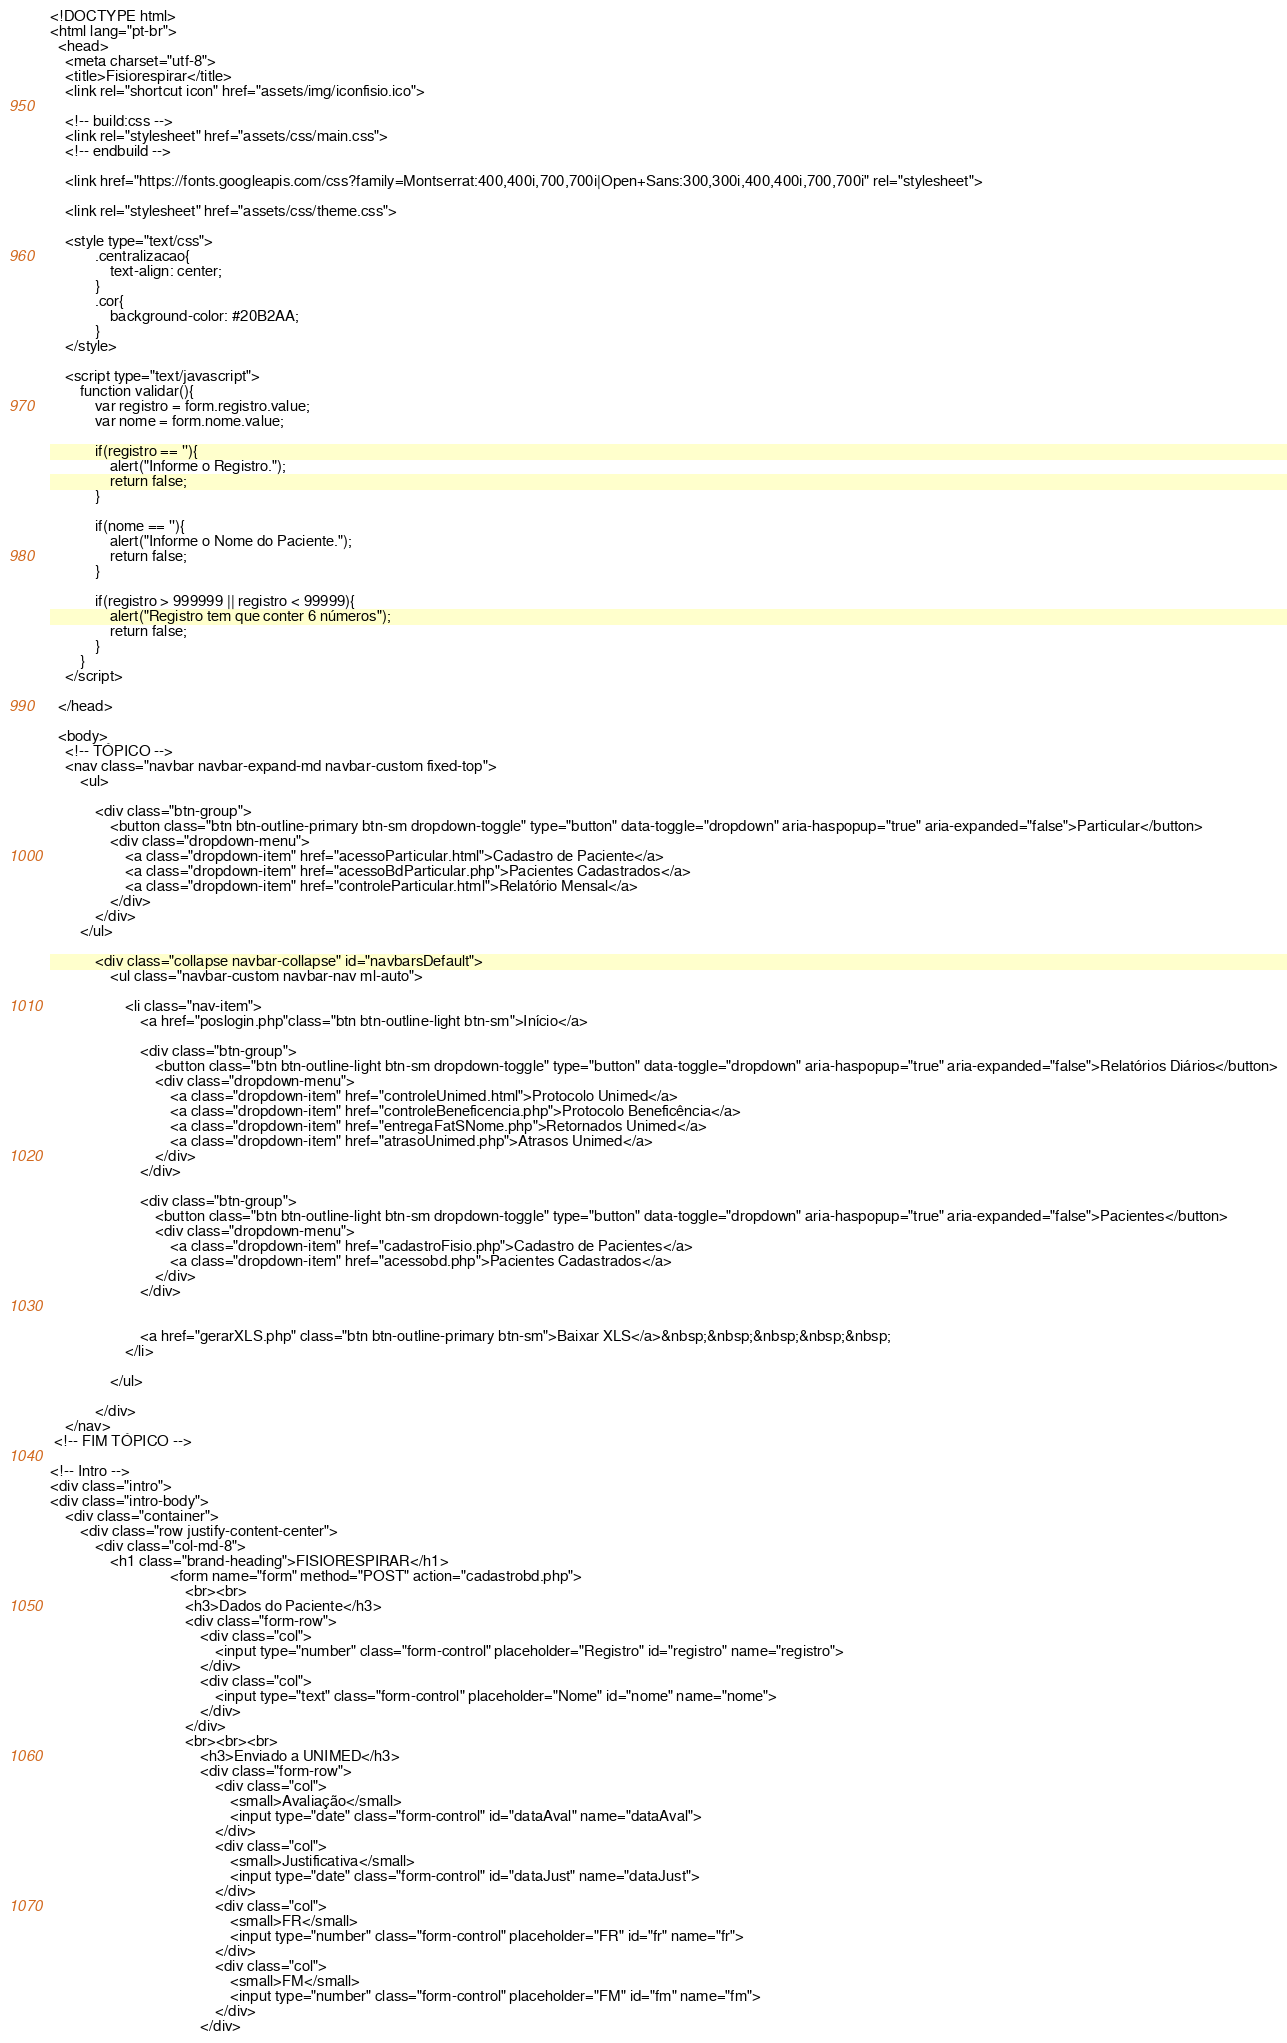<code> <loc_0><loc_0><loc_500><loc_500><_PHP_><!DOCTYPE html>
<html lang="pt-br">
  <head>
    <meta charset="utf-8">
    <title>Fisiorespirar</title>
    <link rel="shortcut icon" href="assets/img/iconfisio.ico">

    <!-- build:css -->
    <link rel="stylesheet" href="assets/css/main.css">
    <!-- endbuild -->
    
    <link href="https://fonts.googleapis.com/css?family=Montserrat:400,400i,700,700i|Open+Sans:300,300i,400,400i,700,700i" rel="stylesheet">
      
    <link rel="stylesheet" href="assets/css/theme.css">
    
    <style type="text/css">
            .centralizacao{
                text-align: center;
            }
            .cor{
                background-color: #20B2AA;
            }
    </style>
    
    <script type="text/javascript">  
        function validar(){
            var registro = form.registro.value;
            var nome = form.nome.value;
            
            if(registro == ''){
                alert("Informe o Registro.");
                return false;
            }       
            
            if(nome == ''){
                alert("Informe o Nome do Paciente.");
                return false;
            }     
            
            if(registro > 999999 || registro < 99999){
                alert("Registro tem que conter 6 números");
                return false;
            }
        }
    </script>
      
  </head>

  <body>     
    <!-- TÓPICO -->
    <nav class="navbar navbar-expand-md navbar-custom fixed-top">
        <ul>
            
            <div class="btn-group">
                <button class="btn btn-outline-primary btn-sm dropdown-toggle" type="button" data-toggle="dropdown" aria-haspopup="true" aria-expanded="false">Particular</button>
                <div class="dropdown-menu"> 
                    <a class="dropdown-item" href="acessoParticular.html">Cadastro de Paciente</a>
                    <a class="dropdown-item" href="acessoBdParticular.php">Pacientes Cadastrados</a>
                    <a class="dropdown-item" href="controleParticular.html">Relatório Mensal</a>                
                </div>
            </div>
        </ul>

            <div class="collapse navbar-collapse" id="navbarsDefault">
                <ul class="navbar-custom navbar-nav ml-auto">
                                        
                    <li class="nav-item">       
                        <a href="poslogin.php"class="btn btn-outline-light btn-sm">Início</a>
                        
                        <div class="btn-group">
                            <button class="btn btn-outline-light btn-sm dropdown-toggle" type="button" data-toggle="dropdown" aria-haspopup="true" aria-expanded="false">Relatórios Diários</button>
                            <div class="dropdown-menu"> 
                                <a class="dropdown-item" href="controleUnimed.html">Protocolo Unimed</a>
                                <a class="dropdown-item" href="controleBeneficencia.php">Protocolo Beneficência</a>
                                <a class="dropdown-item" href="entregaFatSNome.php">Retornados Unimed</a>
                                <a class="dropdown-item" href="atrasoUnimed.php">Atrasos Unimed</a>
                            </div>
                        </div>
                     
                        <div class="btn-group">
                            <button class="btn btn-outline-light btn-sm dropdown-toggle" type="button" data-toggle="dropdown" aria-haspopup="true" aria-expanded="false">Pacientes</button>
                            <div class="dropdown-menu"> 
                                <a class="dropdown-item" href="cadastroFisio.php">Cadastro de Pacientes</a>
                                <a class="dropdown-item" href="acessobd.php">Pacientes Cadastrados</a>                
                            </div>
                        </div>

                    
                        <a href="gerarXLS.php" class="btn btn-outline-primary btn-sm">Baixar XLS</a>&nbsp;&nbsp;&nbsp;&nbsp;&nbsp;
                    </li>  
                    
                </ul>              
                
            </div>
    </nav>
 <!-- FIM TÓPICO -->

<!-- Intro -->
<div class="intro">
<div class="intro-body">
	<div class="container">
		<div class="row justify-content-center">
			<div class="col-md-8">
				<h1 class="brand-heading">FISIORESPIRAR</h1>
                                <form name="form" method="POST" action="cadastrobd.php">
                                    <br><br>
                                    <h3>Dados do Paciente</h3>
                                    <div class="form-row">                                        
                                        <div class="col">
                                            <input type="number" class="form-control" placeholder="Registro" id="registro" name="registro">
                                        </div>
                                        <div class="col">
                                            <input type="text" class="form-control" placeholder="Nome" id="nome" name="nome">
                                        </div>
                                    </div>
                                    <br><br><br>
                                        <h3>Enviado a UNIMED</h3>
                                        <div class="form-row"> 
                                            <div class="col">
                                                <small>Avaliação</small>
                                                <input type="date" class="form-control" id="dataAval" name="dataAval">
                                            </div>
                                            <div class="col">
                                                <small>Justificativa</small>
                                                <input type="date" class="form-control" id="dataJust" name="dataJust">
                                            </div>
                                            <div class="col">
                                                <small>FR</small>
                                                <input type="number" class="form-control" placeholder="FR" id="fr" name="fr">
                                            </div>
                                            <div class="col">
                                                <small>FM</small>
                                                <input type="number" class="form-control" placeholder="FM" id="fm" name="fm">
                                            </div>
                                        </div></code> 